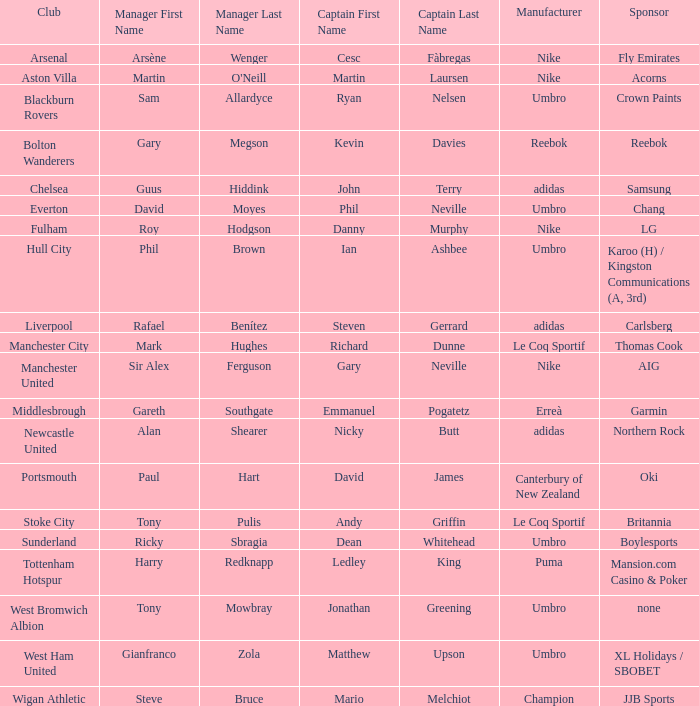Who is the captain of Middlesbrough? Emmanuel Pogatetz. Could you parse the entire table as a dict? {'header': ['Club', 'Manager First Name', 'Manager Last Name', 'Captain First Name', 'Captain Last Name', 'Manufacturer', 'Sponsor'], 'rows': [['Arsenal', 'Arsène', 'Wenger', 'Cesc', 'Fàbregas', 'Nike', 'Fly Emirates'], ['Aston Villa', 'Martin', "O'Neill", 'Martin', 'Laursen', 'Nike', 'Acorns'], ['Blackburn Rovers', 'Sam', 'Allardyce', 'Ryan', 'Nelsen', 'Umbro', 'Crown Paints'], ['Bolton Wanderers', 'Gary', 'Megson', 'Kevin', 'Davies', 'Reebok', 'Reebok'], ['Chelsea', 'Guus', 'Hiddink', 'John', 'Terry', 'adidas', 'Samsung'], ['Everton', 'David', 'Moyes', 'Phil', 'Neville', 'Umbro', 'Chang'], ['Fulham', 'Roy', 'Hodgson', 'Danny', 'Murphy', 'Nike', 'LG'], ['Hull City', 'Phil', 'Brown', 'Ian', 'Ashbee', 'Umbro', 'Karoo (H) / Kingston Communications (A, 3rd)'], ['Liverpool', 'Rafael', 'Benítez', 'Steven', 'Gerrard', 'adidas', 'Carlsberg'], ['Manchester City', 'Mark', 'Hughes', 'Richard', 'Dunne', 'Le Coq Sportif', 'Thomas Cook'], ['Manchester United', 'Sir Alex', 'Ferguson', 'Gary', 'Neville', 'Nike', 'AIG'], ['Middlesbrough', 'Gareth', 'Southgate', 'Emmanuel', 'Pogatetz', 'Erreà', 'Garmin'], ['Newcastle United', 'Alan', 'Shearer', 'Nicky', 'Butt', 'adidas', 'Northern Rock'], ['Portsmouth', 'Paul', 'Hart', 'David', 'James', 'Canterbury of New Zealand', 'Oki'], ['Stoke City', 'Tony', 'Pulis', 'Andy', 'Griffin', 'Le Coq Sportif', 'Britannia'], ['Sunderland', 'Ricky', 'Sbragia', 'Dean', 'Whitehead', 'Umbro', 'Boylesports'], ['Tottenham Hotspur', 'Harry', 'Redknapp', 'Ledley', 'King', 'Puma', 'Mansion.com Casino & Poker'], ['West Bromwich Albion', 'Tony', 'Mowbray', 'Jonathan', 'Greening', 'Umbro', 'none'], ['West Ham United', 'Gianfranco', 'Zola', 'Matthew', 'Upson', 'Umbro', 'XL Holidays / SBOBET'], ['Wigan Athletic', 'Steve', 'Bruce', 'Mario', 'Melchiot', 'Champion', 'JJB Sports']]} 